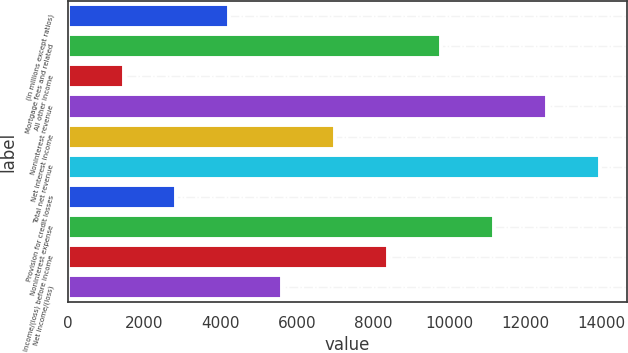<chart> <loc_0><loc_0><loc_500><loc_500><bar_chart><fcel>(in millions except ratios)<fcel>Mortgage fees and related<fcel>All other income<fcel>Noninterest revenue<fcel>Net interest income<fcel>Total net revenue<fcel>Provision for credit losses<fcel>Noninterest expense<fcel>Income/(loss) before income<fcel>Net income/(loss)<nl><fcel>4234.4<fcel>9793.6<fcel>1454.8<fcel>12573.2<fcel>7014<fcel>13963<fcel>2844.6<fcel>11183.4<fcel>8403.8<fcel>5624.2<nl></chart> 